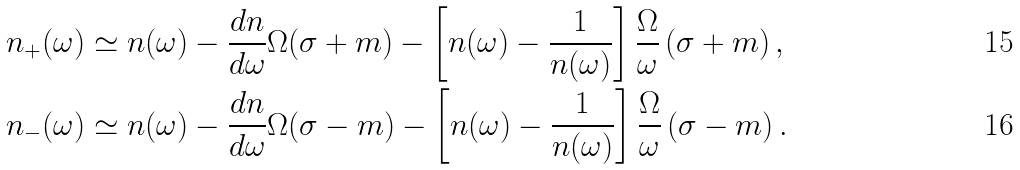<formula> <loc_0><loc_0><loc_500><loc_500>n _ { + } ( \omega ) & \simeq n ( \omega ) - \frac { d n } { d \omega } \Omega ( \sigma + m ) - \left [ n ( \omega ) - \frac { 1 } { n ( \omega ) } \right ] \frac { \Omega } { \omega } \left ( \sigma + m \right ) , \\ n _ { - } ( \omega ) & \simeq n ( \omega ) - \frac { d n } { d \omega } \Omega ( \sigma - m ) - \left [ n ( \omega ) - \frac { 1 } { n ( \omega ) } \right ] \frac { \Omega } { \omega } \left ( \sigma - m \right ) .</formula> 